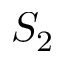Convert formula to latex. <formula><loc_0><loc_0><loc_500><loc_500>S _ { 2 }</formula> 